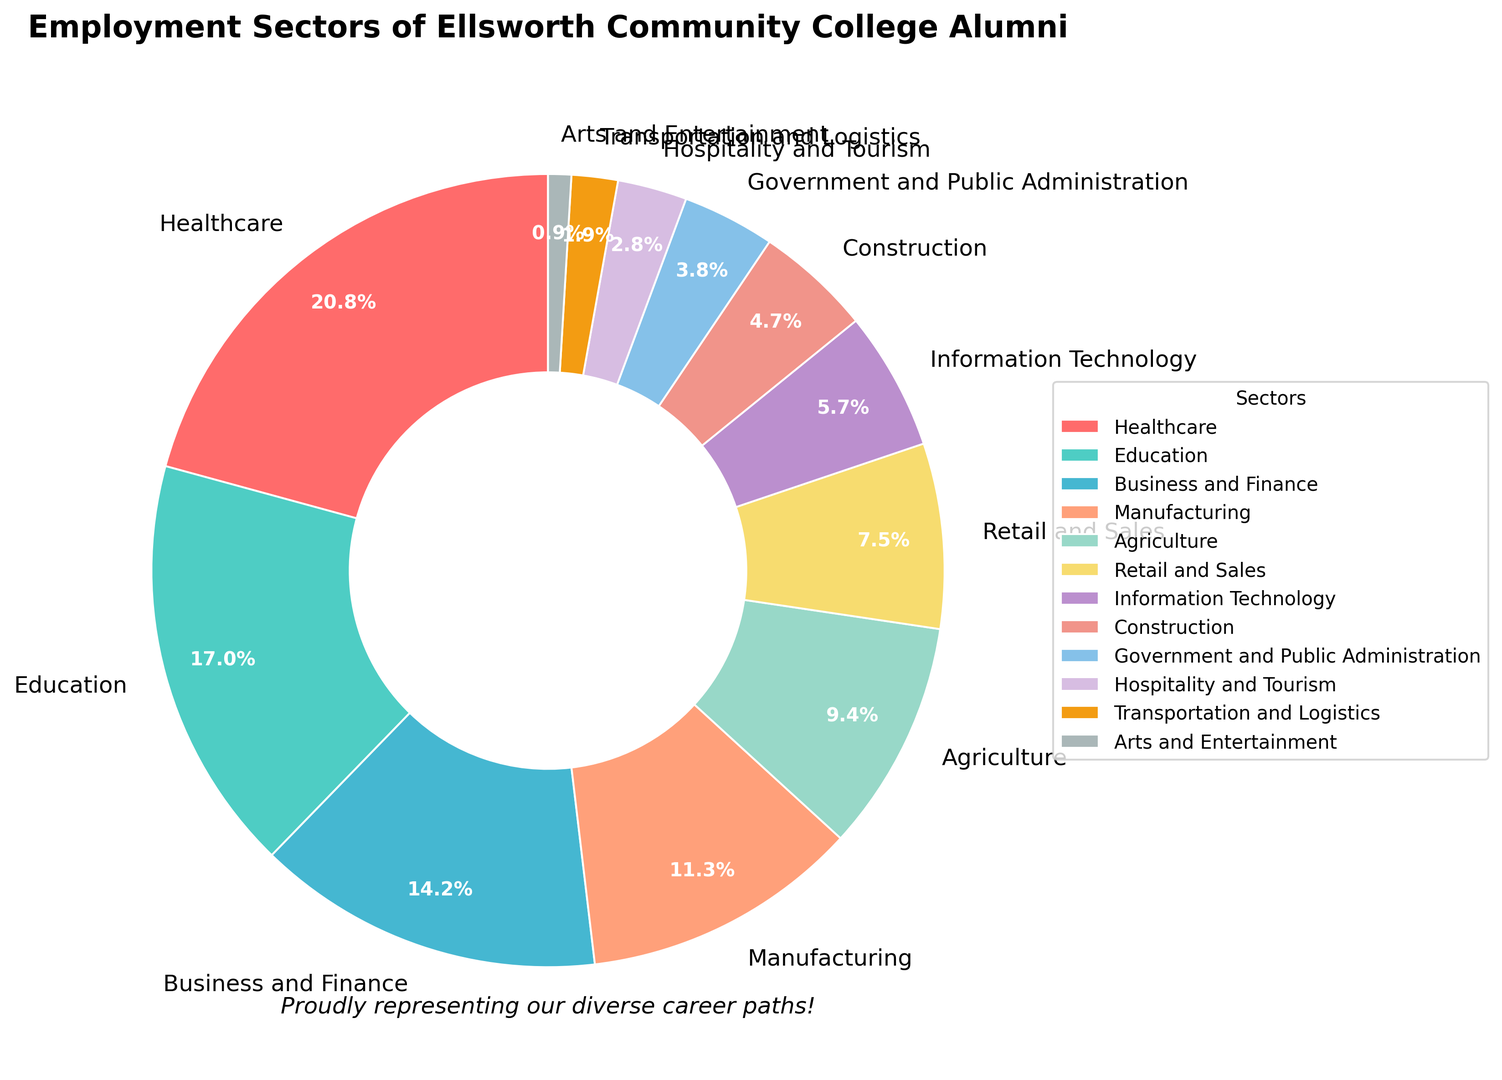What's the most common employment sector among Ellsworth Community College alumni? The pie chart shows various employment sectors with their corresponding percentages. The largest segment represents the most common sector.
Answer: Healthcare Which sector has the smallest representation in the employment sectors of Ellsworth Community College alumni? By identifying the smallest wedge in the pie chart, we can find the sector with the least representation.
Answer: Arts and Entertainment What is the combined percentage of alumni working in Business and Finance, Manufacturing, and Agriculture? Add the percentages for Business and Finance (15%), Manufacturing (12%), and Agriculture (10%) to get the total combined percentage: 15% + 12% + 10% = 37%.
Answer: 37% How many sectors have a higher percentage of alumni employed compared to Retail and Sales? Retail and Sales has a percentage of 8%. The sectors with a higher percentage are Healthcare (22%), Education (18%), Business and Finance (15%), Manufacturing (12%), and Agriculture (10%). Counting these gives us 5 sectors.
Answer: 5 What's the difference in percentage between the sector with the highest and the sector with the lowest alumni employment? The highest percentage is Healthcare (22%) and the lowest is Arts and Entertainment (1%). Calculate the difference: 22% - 1% = 21%.
Answer: 21% Which sectors have a percentage of alumni employment above 15%? Identify the sectors with percentages higher than 15%. These sectors are Healthcare (22%) and Education (18%).
Answer: Healthcare and Education How does the percentage of alumni employed in Information Technology compare to those in Government and Public Administration? Compare the two percentages: Information Technology is 6%, and Government and Public Administration is 4%. Information Technology is higher by 2%.
Answer: Information Technology is higher by 2% What's the combined percentage of alumni working in Retail and Sales, Construction, and Hospitality and Tourism? Add the percentages for Retail and Sales (8%), Construction (5%), and Hospitality and Tourism (3%) to get the total: 8% + 5% + 3% = 16%.
Answer: 16% What percentage of alumni is employed in sectors related to STEM (Science, Technology, Engineering, Mathematics), which could include Information Technology, Manufacturing, and Healthcare? Sum the percentages for Information Technology (6%), Manufacturing (12%), and Healthcare (22%): 6% + 12% + 22% = 40%.
Answer: 40% Which sector, Agriculture or Government and Public Administration, has a higher percentage of alumni employment, and by how much? Compare Agriculture (10%) with Government and Public Administration (4%). Agriculture is higher by 6%.
Answer: Agriculture is higher by 6% 